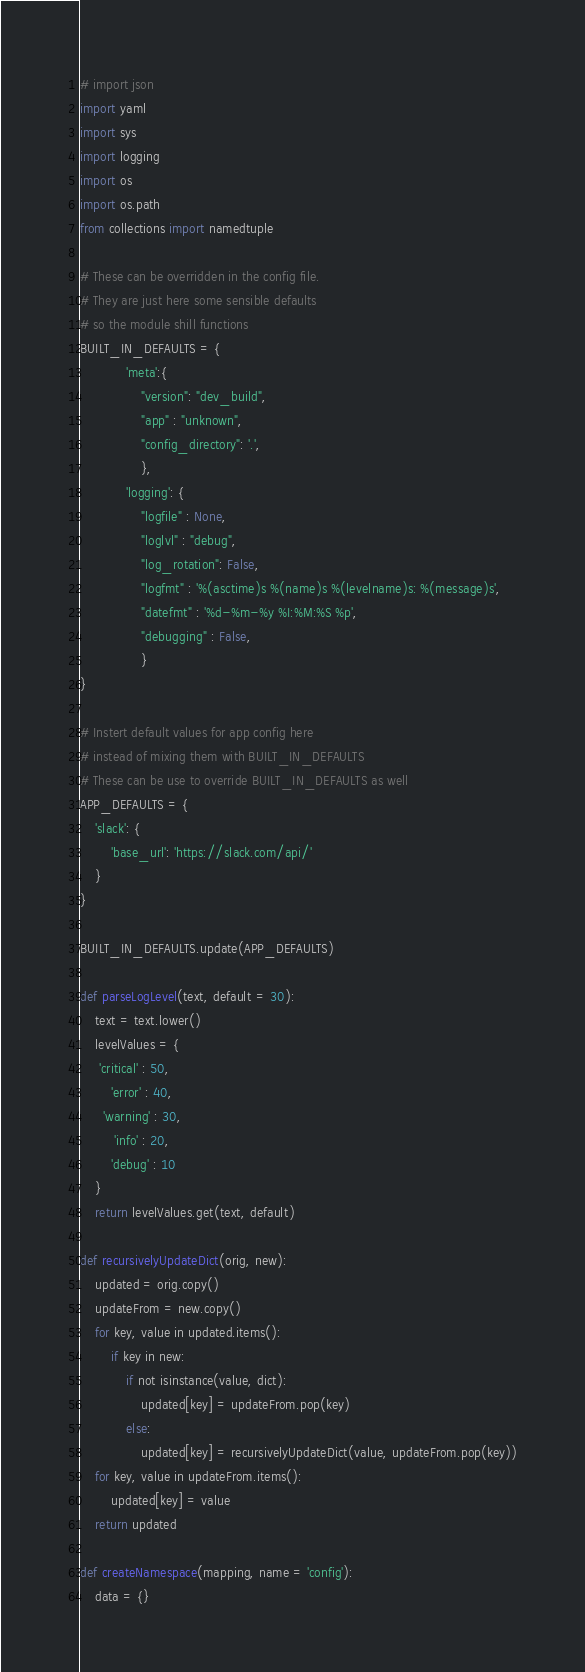Convert code to text. <code><loc_0><loc_0><loc_500><loc_500><_Python_># import json
import yaml
import sys
import logging
import os
import os.path
from collections import namedtuple

# These can be overridden in the config file. 
# They are just here some sensible defaults
# so the module shill functions
BUILT_IN_DEFAULTS = { 
			'meta':{
				"version": "dev_build",
				"app" : "unknown",
				"config_directory": '.',				
				},
			'logging': {
				"logfile" : None,
				"loglvl" : "debug",
				"log_rotation": False,
				"logfmt" : '%(asctime)s %(name)s %(levelname)s: %(message)s',
				"datefmt" : '%d-%m-%y %I:%M:%S %p',
				"debugging" : False,
				}
}

# Instert default values for app config here 
# instead of mixing them with BUILT_IN_DEFAULTS
# These can be use to override BUILT_IN_DEFAULTS as well
APP_DEFAULTS = {
	'slack': {
		'base_url': 'https://slack.com/api/'
	}
}

BUILT_IN_DEFAULTS.update(APP_DEFAULTS)

def parseLogLevel(text, default = 30):
	text = text.lower()
	levelValues = {
	 'critical' : 50,
		'error' : 40,
	  'warning' : 30,
		 'info' : 20,
		'debug' : 10
	}
	return levelValues.get(text, default)

def recursivelyUpdateDict(orig, new):
	updated = orig.copy()
	updateFrom = new.copy()
	for key, value in updated.items():
		if key in new:
			if not isinstance(value, dict):
				updated[key] = updateFrom.pop(key)
			else:
				updated[key] = recursivelyUpdateDict(value, updateFrom.pop(key))
	for key, value in updateFrom.items():
		updated[key] = value
	return updated

def createNamespace(mapping, name = 'config'):
	data = {}</code> 